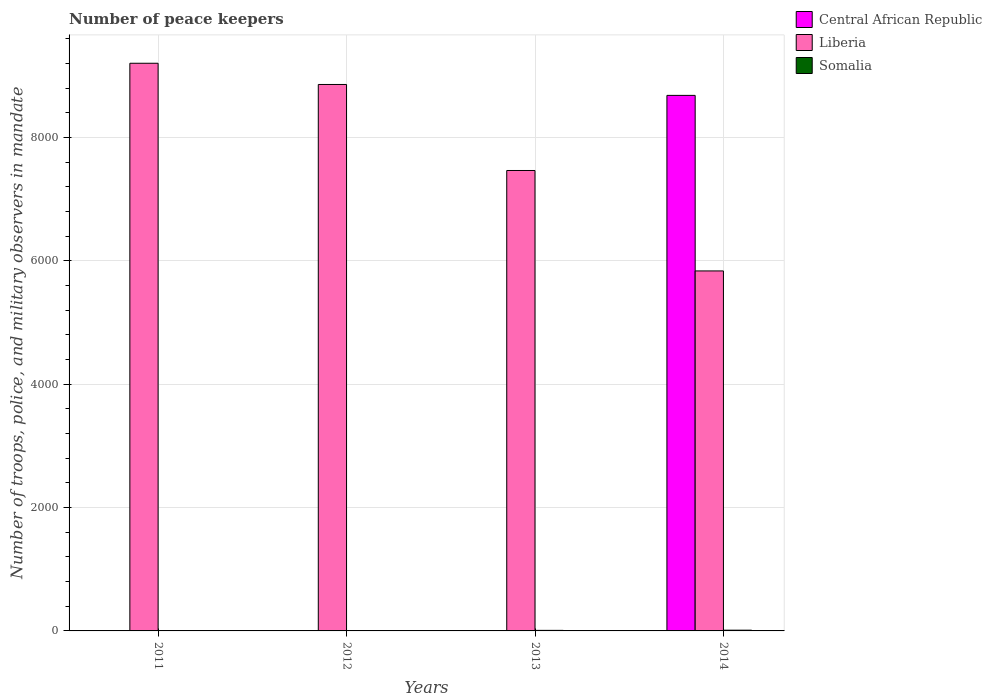How many different coloured bars are there?
Offer a very short reply. 3. How many bars are there on the 1st tick from the left?
Offer a very short reply. 3. How many bars are there on the 1st tick from the right?
Your response must be concise. 3. Across all years, what is the maximum number of peace keepers in in Central African Republic?
Offer a terse response. 8685. Across all years, what is the minimum number of peace keepers in in Central African Republic?
Your response must be concise. 4. In which year was the number of peace keepers in in Liberia maximum?
Your answer should be compact. 2011. In which year was the number of peace keepers in in Liberia minimum?
Provide a succinct answer. 2014. What is the total number of peace keepers in in Central African Republic in the graph?
Ensure brevity in your answer.  8697. What is the difference between the number of peace keepers in in Somalia in 2012 and that in 2013?
Provide a succinct answer. -6. What is the difference between the number of peace keepers in in Liberia in 2011 and the number of peace keepers in in Central African Republic in 2013?
Ensure brevity in your answer.  9202. In the year 2013, what is the difference between the number of peace keepers in in Liberia and number of peace keepers in in Somalia?
Ensure brevity in your answer.  7458. Is the number of peace keepers in in Central African Republic in 2012 less than that in 2013?
Offer a terse response. No. What is the difference between the highest and the second highest number of peace keepers in in Liberia?
Ensure brevity in your answer.  344. In how many years, is the number of peace keepers in in Central African Republic greater than the average number of peace keepers in in Central African Republic taken over all years?
Offer a terse response. 1. Is the sum of the number of peace keepers in in Liberia in 2012 and 2014 greater than the maximum number of peace keepers in in Somalia across all years?
Your answer should be very brief. Yes. What does the 2nd bar from the left in 2011 represents?
Your answer should be compact. Liberia. What does the 3rd bar from the right in 2014 represents?
Keep it short and to the point. Central African Republic. Is it the case that in every year, the sum of the number of peace keepers in in Somalia and number of peace keepers in in Liberia is greater than the number of peace keepers in in Central African Republic?
Offer a terse response. No. Are all the bars in the graph horizontal?
Give a very brief answer. No. Where does the legend appear in the graph?
Ensure brevity in your answer.  Top right. How many legend labels are there?
Provide a short and direct response. 3. What is the title of the graph?
Provide a succinct answer. Number of peace keepers. Does "Poland" appear as one of the legend labels in the graph?
Your answer should be very brief. No. What is the label or title of the Y-axis?
Ensure brevity in your answer.  Number of troops, police, and military observers in mandate. What is the Number of troops, police, and military observers in mandate of Central African Republic in 2011?
Offer a terse response. 4. What is the Number of troops, police, and military observers in mandate in Liberia in 2011?
Offer a terse response. 9206. What is the Number of troops, police, and military observers in mandate of Central African Republic in 2012?
Your response must be concise. 4. What is the Number of troops, police, and military observers in mandate of Liberia in 2012?
Ensure brevity in your answer.  8862. What is the Number of troops, police, and military observers in mandate of Somalia in 2012?
Your response must be concise. 3. What is the Number of troops, police, and military observers in mandate in Liberia in 2013?
Your answer should be very brief. 7467. What is the Number of troops, police, and military observers in mandate in Central African Republic in 2014?
Offer a very short reply. 8685. What is the Number of troops, police, and military observers in mandate in Liberia in 2014?
Your answer should be very brief. 5838. Across all years, what is the maximum Number of troops, police, and military observers in mandate in Central African Republic?
Offer a terse response. 8685. Across all years, what is the maximum Number of troops, police, and military observers in mandate in Liberia?
Provide a short and direct response. 9206. Across all years, what is the maximum Number of troops, police, and military observers in mandate in Somalia?
Offer a very short reply. 12. Across all years, what is the minimum Number of troops, police, and military observers in mandate of Central African Republic?
Provide a short and direct response. 4. Across all years, what is the minimum Number of troops, police, and military observers in mandate in Liberia?
Offer a terse response. 5838. What is the total Number of troops, police, and military observers in mandate of Central African Republic in the graph?
Make the answer very short. 8697. What is the total Number of troops, police, and military observers in mandate in Liberia in the graph?
Your answer should be compact. 3.14e+04. What is the total Number of troops, police, and military observers in mandate of Somalia in the graph?
Your answer should be very brief. 30. What is the difference between the Number of troops, police, and military observers in mandate in Central African Republic in 2011 and that in 2012?
Your answer should be very brief. 0. What is the difference between the Number of troops, police, and military observers in mandate in Liberia in 2011 and that in 2012?
Your answer should be very brief. 344. What is the difference between the Number of troops, police, and military observers in mandate in Central African Republic in 2011 and that in 2013?
Offer a terse response. 0. What is the difference between the Number of troops, police, and military observers in mandate of Liberia in 2011 and that in 2013?
Provide a short and direct response. 1739. What is the difference between the Number of troops, police, and military observers in mandate of Somalia in 2011 and that in 2013?
Ensure brevity in your answer.  -3. What is the difference between the Number of troops, police, and military observers in mandate of Central African Republic in 2011 and that in 2014?
Your answer should be very brief. -8681. What is the difference between the Number of troops, police, and military observers in mandate in Liberia in 2011 and that in 2014?
Provide a succinct answer. 3368. What is the difference between the Number of troops, police, and military observers in mandate in Central African Republic in 2012 and that in 2013?
Make the answer very short. 0. What is the difference between the Number of troops, police, and military observers in mandate in Liberia in 2012 and that in 2013?
Offer a very short reply. 1395. What is the difference between the Number of troops, police, and military observers in mandate in Central African Republic in 2012 and that in 2014?
Provide a short and direct response. -8681. What is the difference between the Number of troops, police, and military observers in mandate of Liberia in 2012 and that in 2014?
Offer a terse response. 3024. What is the difference between the Number of troops, police, and military observers in mandate in Central African Republic in 2013 and that in 2014?
Keep it short and to the point. -8681. What is the difference between the Number of troops, police, and military observers in mandate of Liberia in 2013 and that in 2014?
Make the answer very short. 1629. What is the difference between the Number of troops, police, and military observers in mandate of Central African Republic in 2011 and the Number of troops, police, and military observers in mandate of Liberia in 2012?
Your answer should be very brief. -8858. What is the difference between the Number of troops, police, and military observers in mandate of Liberia in 2011 and the Number of troops, police, and military observers in mandate of Somalia in 2012?
Your answer should be compact. 9203. What is the difference between the Number of troops, police, and military observers in mandate of Central African Republic in 2011 and the Number of troops, police, and military observers in mandate of Liberia in 2013?
Make the answer very short. -7463. What is the difference between the Number of troops, police, and military observers in mandate in Liberia in 2011 and the Number of troops, police, and military observers in mandate in Somalia in 2013?
Provide a short and direct response. 9197. What is the difference between the Number of troops, police, and military observers in mandate in Central African Republic in 2011 and the Number of troops, police, and military observers in mandate in Liberia in 2014?
Ensure brevity in your answer.  -5834. What is the difference between the Number of troops, police, and military observers in mandate in Liberia in 2011 and the Number of troops, police, and military observers in mandate in Somalia in 2014?
Offer a terse response. 9194. What is the difference between the Number of troops, police, and military observers in mandate of Central African Republic in 2012 and the Number of troops, police, and military observers in mandate of Liberia in 2013?
Provide a succinct answer. -7463. What is the difference between the Number of troops, police, and military observers in mandate of Central African Republic in 2012 and the Number of troops, police, and military observers in mandate of Somalia in 2013?
Offer a very short reply. -5. What is the difference between the Number of troops, police, and military observers in mandate of Liberia in 2012 and the Number of troops, police, and military observers in mandate of Somalia in 2013?
Your answer should be compact. 8853. What is the difference between the Number of troops, police, and military observers in mandate of Central African Republic in 2012 and the Number of troops, police, and military observers in mandate of Liberia in 2014?
Ensure brevity in your answer.  -5834. What is the difference between the Number of troops, police, and military observers in mandate of Liberia in 2012 and the Number of troops, police, and military observers in mandate of Somalia in 2014?
Your response must be concise. 8850. What is the difference between the Number of troops, police, and military observers in mandate in Central African Republic in 2013 and the Number of troops, police, and military observers in mandate in Liberia in 2014?
Your response must be concise. -5834. What is the difference between the Number of troops, police, and military observers in mandate in Liberia in 2013 and the Number of troops, police, and military observers in mandate in Somalia in 2014?
Give a very brief answer. 7455. What is the average Number of troops, police, and military observers in mandate in Central African Republic per year?
Provide a short and direct response. 2174.25. What is the average Number of troops, police, and military observers in mandate in Liberia per year?
Ensure brevity in your answer.  7843.25. What is the average Number of troops, police, and military observers in mandate in Somalia per year?
Your answer should be compact. 7.5. In the year 2011, what is the difference between the Number of troops, police, and military observers in mandate in Central African Republic and Number of troops, police, and military observers in mandate in Liberia?
Provide a succinct answer. -9202. In the year 2011, what is the difference between the Number of troops, police, and military observers in mandate of Liberia and Number of troops, police, and military observers in mandate of Somalia?
Offer a terse response. 9200. In the year 2012, what is the difference between the Number of troops, police, and military observers in mandate of Central African Republic and Number of troops, police, and military observers in mandate of Liberia?
Provide a succinct answer. -8858. In the year 2012, what is the difference between the Number of troops, police, and military observers in mandate in Central African Republic and Number of troops, police, and military observers in mandate in Somalia?
Provide a short and direct response. 1. In the year 2012, what is the difference between the Number of troops, police, and military observers in mandate of Liberia and Number of troops, police, and military observers in mandate of Somalia?
Make the answer very short. 8859. In the year 2013, what is the difference between the Number of troops, police, and military observers in mandate in Central African Republic and Number of troops, police, and military observers in mandate in Liberia?
Your answer should be compact. -7463. In the year 2013, what is the difference between the Number of troops, police, and military observers in mandate of Central African Republic and Number of troops, police, and military observers in mandate of Somalia?
Your response must be concise. -5. In the year 2013, what is the difference between the Number of troops, police, and military observers in mandate in Liberia and Number of troops, police, and military observers in mandate in Somalia?
Your answer should be very brief. 7458. In the year 2014, what is the difference between the Number of troops, police, and military observers in mandate of Central African Republic and Number of troops, police, and military observers in mandate of Liberia?
Give a very brief answer. 2847. In the year 2014, what is the difference between the Number of troops, police, and military observers in mandate of Central African Republic and Number of troops, police, and military observers in mandate of Somalia?
Offer a very short reply. 8673. In the year 2014, what is the difference between the Number of troops, police, and military observers in mandate of Liberia and Number of troops, police, and military observers in mandate of Somalia?
Your response must be concise. 5826. What is the ratio of the Number of troops, police, and military observers in mandate in Central African Republic in 2011 to that in 2012?
Your response must be concise. 1. What is the ratio of the Number of troops, police, and military observers in mandate in Liberia in 2011 to that in 2012?
Your answer should be very brief. 1.04. What is the ratio of the Number of troops, police, and military observers in mandate of Somalia in 2011 to that in 2012?
Offer a very short reply. 2. What is the ratio of the Number of troops, police, and military observers in mandate in Central African Republic in 2011 to that in 2013?
Make the answer very short. 1. What is the ratio of the Number of troops, police, and military observers in mandate in Liberia in 2011 to that in 2013?
Your answer should be compact. 1.23. What is the ratio of the Number of troops, police, and military observers in mandate in Central African Republic in 2011 to that in 2014?
Provide a short and direct response. 0. What is the ratio of the Number of troops, police, and military observers in mandate of Liberia in 2011 to that in 2014?
Provide a succinct answer. 1.58. What is the ratio of the Number of troops, police, and military observers in mandate of Central African Republic in 2012 to that in 2013?
Ensure brevity in your answer.  1. What is the ratio of the Number of troops, police, and military observers in mandate in Liberia in 2012 to that in 2013?
Give a very brief answer. 1.19. What is the ratio of the Number of troops, police, and military observers in mandate of Central African Republic in 2012 to that in 2014?
Provide a succinct answer. 0. What is the ratio of the Number of troops, police, and military observers in mandate of Liberia in 2012 to that in 2014?
Your answer should be compact. 1.52. What is the ratio of the Number of troops, police, and military observers in mandate of Somalia in 2012 to that in 2014?
Ensure brevity in your answer.  0.25. What is the ratio of the Number of troops, police, and military observers in mandate in Liberia in 2013 to that in 2014?
Your answer should be compact. 1.28. What is the difference between the highest and the second highest Number of troops, police, and military observers in mandate of Central African Republic?
Offer a terse response. 8681. What is the difference between the highest and the second highest Number of troops, police, and military observers in mandate of Liberia?
Provide a succinct answer. 344. What is the difference between the highest and the second highest Number of troops, police, and military observers in mandate in Somalia?
Offer a terse response. 3. What is the difference between the highest and the lowest Number of troops, police, and military observers in mandate in Central African Republic?
Make the answer very short. 8681. What is the difference between the highest and the lowest Number of troops, police, and military observers in mandate of Liberia?
Ensure brevity in your answer.  3368. 